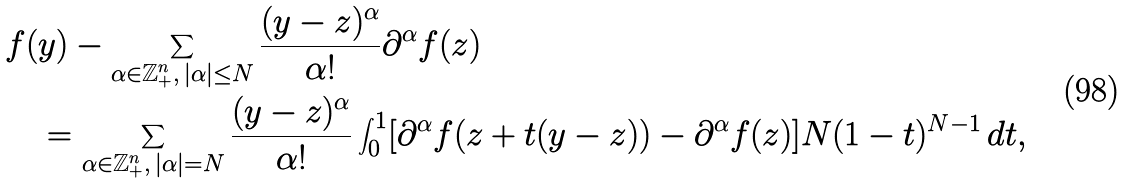<formula> <loc_0><loc_0><loc_500><loc_500>& f ( y ) - \sum _ { \alpha \in \mathbb { Z } _ { + } ^ { n } , \, | \alpha | \leq N } \frac { ( y - z ) ^ { \alpha } } { \alpha ! } \partial ^ { \alpha } f ( z ) \\ & \quad = \sum _ { \alpha \in \mathbb { Z } _ { + } ^ { n } , \, | \alpha | = N } \frac { ( y - z ) ^ { \alpha } } { \alpha ! } \int _ { 0 } ^ { 1 } [ \partial ^ { \alpha } f ( z + t ( y - z ) ) - \partial ^ { \alpha } f ( z ) ] N ( 1 - t ) ^ { N - 1 } \, d t ,</formula> 